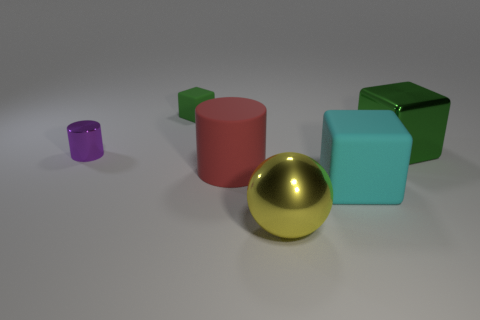What is the shape of the big object that is the same color as the tiny rubber object?
Give a very brief answer. Cube. What is the size of the matte block in front of the green object that is to the left of the yellow object?
Ensure brevity in your answer.  Large. What number of cubes are tiny purple things or large things?
Your response must be concise. 2. There is another shiny object that is the same size as the yellow thing; what is its color?
Your response must be concise. Green. What is the shape of the large thing that is in front of the block in front of the large cylinder?
Provide a succinct answer. Sphere. Do the rubber thing that is to the left of the red cylinder and the cyan object have the same size?
Your response must be concise. No. What number of other things are there of the same material as the small purple thing
Provide a short and direct response. 2. What number of purple objects are either small rubber cubes or large spheres?
Keep it short and to the point. 0. The shiny thing that is the same color as the small cube is what size?
Provide a short and direct response. Large. What number of large metal balls are on the left side of the green shiny object?
Keep it short and to the point. 1. 